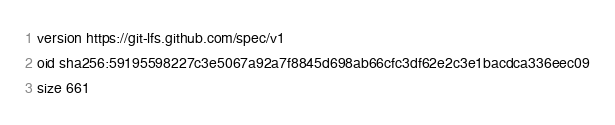<code> <loc_0><loc_0><loc_500><loc_500><_YAML_>version https://git-lfs.github.com/spec/v1
oid sha256:59195598227c3e5067a92a7f8845d698ab66cfc3df62e2c3e1bacdca336eec09
size 661
</code> 